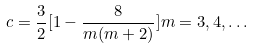Convert formula to latex. <formula><loc_0><loc_0><loc_500><loc_500>c = \frac { 3 } { 2 } [ 1 - \frac { 8 } { m ( m + 2 ) } ] m = 3 , 4 , \dots</formula> 